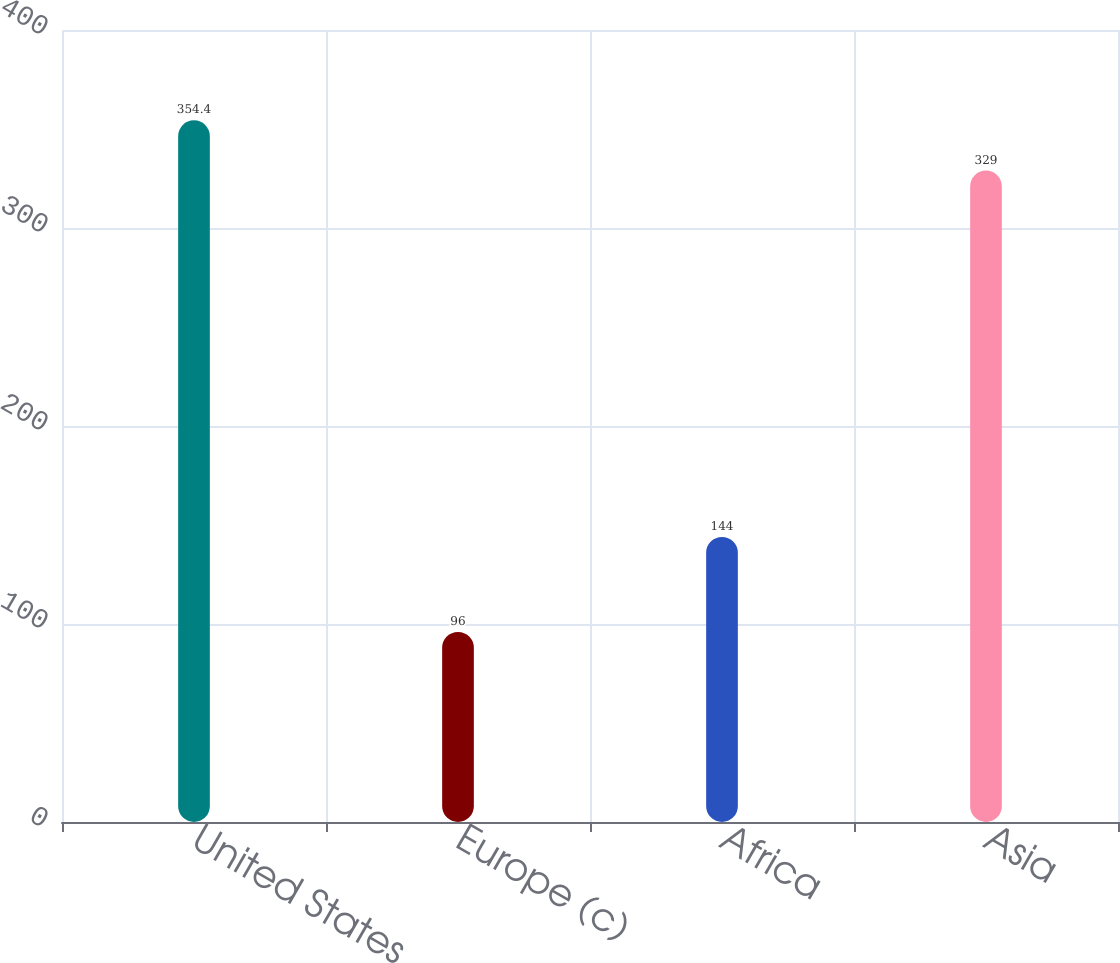<chart> <loc_0><loc_0><loc_500><loc_500><bar_chart><fcel>United States<fcel>Europe (c)<fcel>Africa<fcel>Asia<nl><fcel>354.4<fcel>96<fcel>144<fcel>329<nl></chart> 